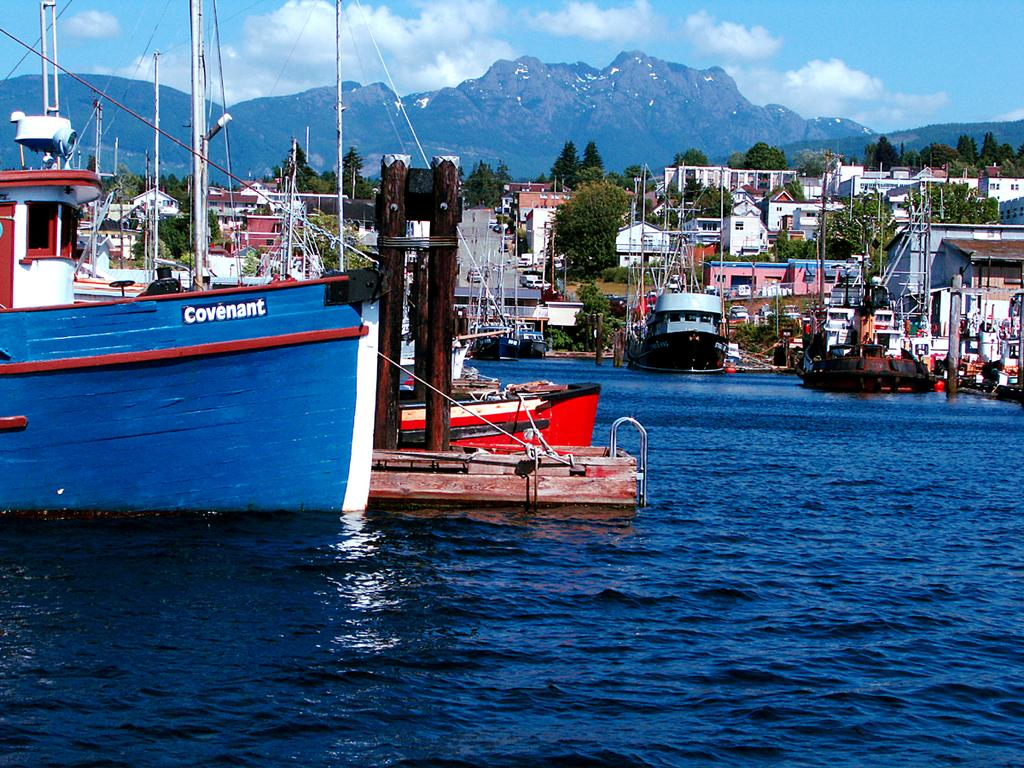What is located on the water in the image? There are ships on the water in the image. What type of vegetation can be seen in the image? There are trees visible in the image. What structures are present in the image? There are poles, vehicles, and buildings in the image. What is visible in the background of the image? There is a mountain and sky visible in the background. What can be seen in the sky? There are clouds in the sky. What type of rake is being used to maintain the boundary in the image? There is no rake or boundary present in the image. What punishment is being administered to the person in the image? There is no person or punishment depicted in the image. 